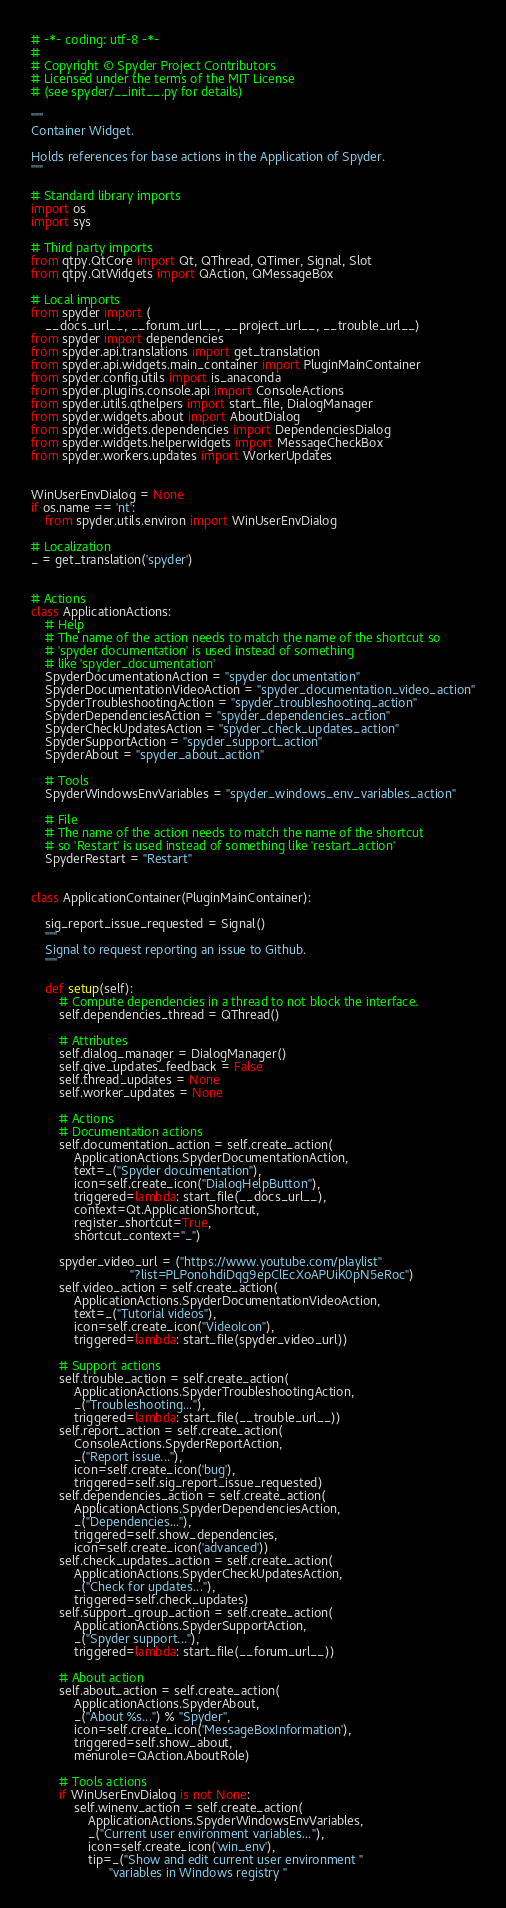<code> <loc_0><loc_0><loc_500><loc_500><_Python_># -*- coding: utf-8 -*-
#
# Copyright © Spyder Project Contributors
# Licensed under the terms of the MIT License
# (see spyder/__init__.py for details)

"""
Container Widget.

Holds references for base actions in the Application of Spyder.
"""

# Standard library imports
import os
import sys

# Third party imports
from qtpy.QtCore import Qt, QThread, QTimer, Signal, Slot
from qtpy.QtWidgets import QAction, QMessageBox

# Local imports
from spyder import (
    __docs_url__, __forum_url__, __project_url__, __trouble_url__)
from spyder import dependencies
from spyder.api.translations import get_translation
from spyder.api.widgets.main_container import PluginMainContainer
from spyder.config.utils import is_anaconda
from spyder.plugins.console.api import ConsoleActions
from spyder.utils.qthelpers import start_file, DialogManager
from spyder.widgets.about import AboutDialog
from spyder.widgets.dependencies import DependenciesDialog
from spyder.widgets.helperwidgets import MessageCheckBox
from spyder.workers.updates import WorkerUpdates


WinUserEnvDialog = None
if os.name == 'nt':
    from spyder.utils.environ import WinUserEnvDialog

# Localization
_ = get_translation('spyder')


# Actions
class ApplicationActions:
    # Help
    # The name of the action needs to match the name of the shortcut so
    # 'spyder documentation' is used instead of something
    # like 'spyder_documentation'
    SpyderDocumentationAction = "spyder documentation"
    SpyderDocumentationVideoAction = "spyder_documentation_video_action"
    SpyderTroubleshootingAction = "spyder_troubleshooting_action"
    SpyderDependenciesAction = "spyder_dependencies_action"
    SpyderCheckUpdatesAction = "spyder_check_updates_action"
    SpyderSupportAction = "spyder_support_action"
    SpyderAbout = "spyder_about_action"

    # Tools
    SpyderWindowsEnvVariables = "spyder_windows_env_variables_action"

    # File
    # The name of the action needs to match the name of the shortcut
    # so 'Restart' is used instead of something like 'restart_action'
    SpyderRestart = "Restart"


class ApplicationContainer(PluginMainContainer):

    sig_report_issue_requested = Signal()
    """
    Signal to request reporting an issue to Github.
    """

    def setup(self):
        # Compute dependencies in a thread to not block the interface.
        self.dependencies_thread = QThread()

        # Attributes
        self.dialog_manager = DialogManager()
        self.give_updates_feedback = False
        self.thread_updates = None
        self.worker_updates = None

        # Actions
        # Documentation actions
        self.documentation_action = self.create_action(
            ApplicationActions.SpyderDocumentationAction,
            text=_("Spyder documentation"),
            icon=self.create_icon("DialogHelpButton"),
            triggered=lambda: start_file(__docs_url__),
            context=Qt.ApplicationShortcut,
            register_shortcut=True,
            shortcut_context="_")

        spyder_video_url = ("https://www.youtube.com/playlist"
                            "?list=PLPonohdiDqg9epClEcXoAPUiK0pN5eRoc")
        self.video_action = self.create_action(
            ApplicationActions.SpyderDocumentationVideoAction,
            text=_("Tutorial videos"),
            icon=self.create_icon("VideoIcon"),
            triggered=lambda: start_file(spyder_video_url))

        # Support actions
        self.trouble_action = self.create_action(
            ApplicationActions.SpyderTroubleshootingAction,
            _("Troubleshooting..."),
            triggered=lambda: start_file(__trouble_url__))
        self.report_action = self.create_action(
            ConsoleActions.SpyderReportAction,
            _("Report issue..."),
            icon=self.create_icon('bug'),
            triggered=self.sig_report_issue_requested)
        self.dependencies_action = self.create_action(
            ApplicationActions.SpyderDependenciesAction,
            _("Dependencies..."),
            triggered=self.show_dependencies,
            icon=self.create_icon('advanced'))
        self.check_updates_action = self.create_action(
            ApplicationActions.SpyderCheckUpdatesAction,
            _("Check for updates..."),
            triggered=self.check_updates)
        self.support_group_action = self.create_action(
            ApplicationActions.SpyderSupportAction,
            _("Spyder support..."),
            triggered=lambda: start_file(__forum_url__))

        # About action
        self.about_action = self.create_action(
            ApplicationActions.SpyderAbout,
            _("About %s...") % "Spyder",
            icon=self.create_icon('MessageBoxInformation'),
            triggered=self.show_about,
            menurole=QAction.AboutRole)

        # Tools actions
        if WinUserEnvDialog is not None:
            self.winenv_action = self.create_action(
                ApplicationActions.SpyderWindowsEnvVariables,
                _("Current user environment variables..."),
                icon=self.create_icon('win_env'),
                tip=_("Show and edit current user environment "
                      "variables in Windows registry "</code> 